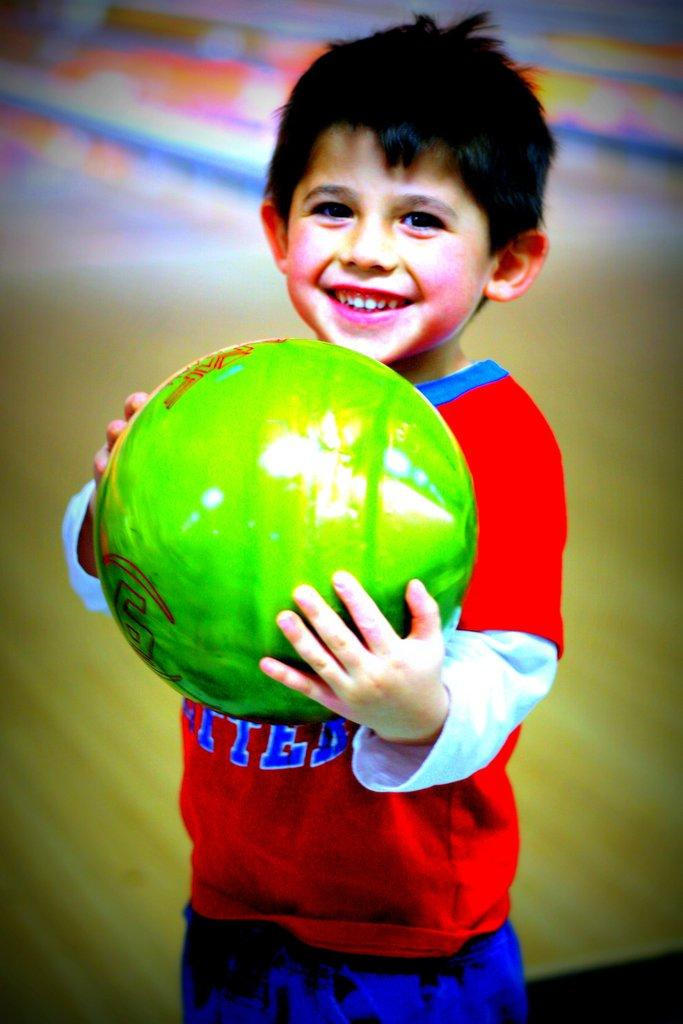What is the main subject of the image? There is a child in the image. What is the child wearing? The child is wearing a red t-shirt and blue pants. What is the child holding in his hand? The child is holding a green ball in his hand. Can you describe the background of the image? The background of the image is blurry. What type of scissors can be seen in the child's hand in the image? There are no scissors present in the image; the child is holding a green ball. What is the child learning in the image? There is no indication of the child learning anything in the image. 